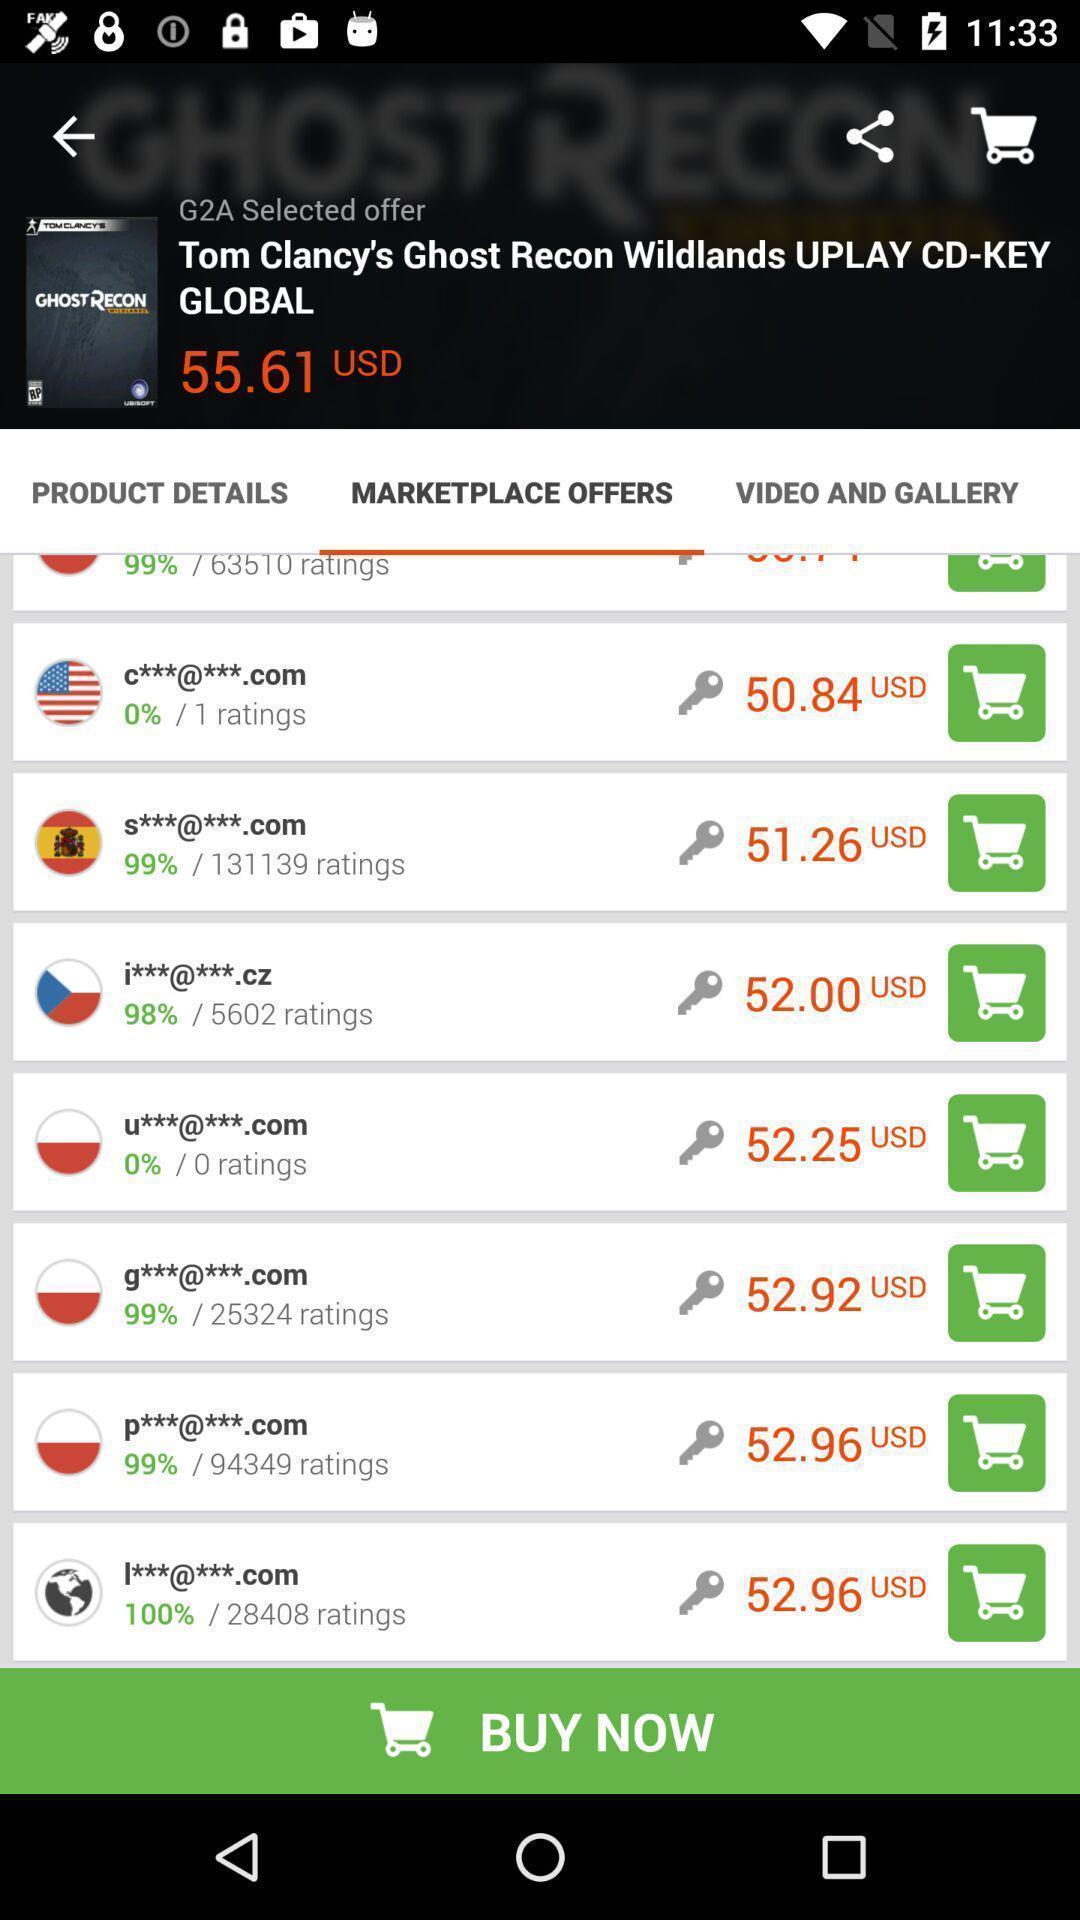What is the overall content of this screenshot? Page showing variety of currencies. 